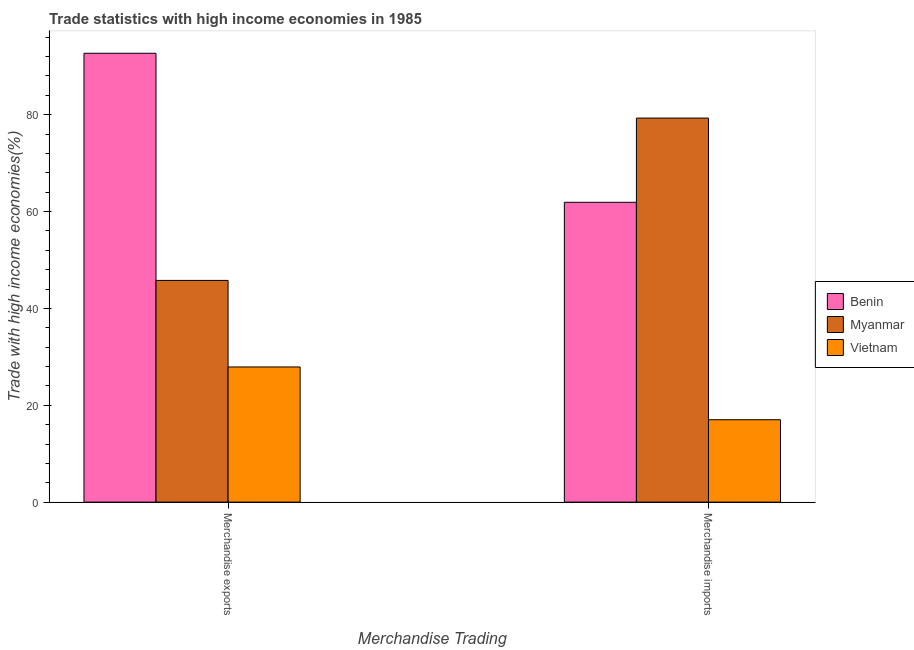How many different coloured bars are there?
Your response must be concise. 3. Are the number of bars per tick equal to the number of legend labels?
Provide a succinct answer. Yes. Are the number of bars on each tick of the X-axis equal?
Your response must be concise. Yes. How many bars are there on the 1st tick from the right?
Offer a terse response. 3. What is the merchandise imports in Myanmar?
Give a very brief answer. 79.29. Across all countries, what is the maximum merchandise exports?
Provide a succinct answer. 92.67. Across all countries, what is the minimum merchandise exports?
Your answer should be very brief. 27.91. In which country was the merchandise imports maximum?
Your response must be concise. Myanmar. In which country was the merchandise imports minimum?
Offer a very short reply. Vietnam. What is the total merchandise imports in the graph?
Your response must be concise. 158.21. What is the difference between the merchandise exports in Vietnam and that in Benin?
Make the answer very short. -64.77. What is the difference between the merchandise imports in Vietnam and the merchandise exports in Benin?
Your answer should be compact. -75.66. What is the average merchandise exports per country?
Your answer should be compact. 55.45. What is the difference between the merchandise exports and merchandise imports in Vietnam?
Your answer should be compact. 10.89. In how many countries, is the merchandise imports greater than 40 %?
Your answer should be compact. 2. What is the ratio of the merchandise exports in Myanmar to that in Benin?
Offer a very short reply. 0.49. Is the merchandise imports in Benin less than that in Myanmar?
Offer a terse response. Yes. What does the 1st bar from the left in Merchandise imports represents?
Your response must be concise. Benin. What does the 3rd bar from the right in Merchandise imports represents?
Keep it short and to the point. Benin. How many bars are there?
Your answer should be very brief. 6. How many countries are there in the graph?
Your answer should be very brief. 3. Does the graph contain grids?
Offer a very short reply. No. Where does the legend appear in the graph?
Provide a short and direct response. Center right. How many legend labels are there?
Your answer should be very brief. 3. How are the legend labels stacked?
Keep it short and to the point. Vertical. What is the title of the graph?
Your answer should be very brief. Trade statistics with high income economies in 1985. Does "Maldives" appear as one of the legend labels in the graph?
Keep it short and to the point. No. What is the label or title of the X-axis?
Your answer should be compact. Merchandise Trading. What is the label or title of the Y-axis?
Give a very brief answer. Trade with high income economies(%). What is the Trade with high income economies(%) in Benin in Merchandise exports?
Your response must be concise. 92.67. What is the Trade with high income economies(%) of Myanmar in Merchandise exports?
Give a very brief answer. 45.78. What is the Trade with high income economies(%) in Vietnam in Merchandise exports?
Offer a very short reply. 27.91. What is the Trade with high income economies(%) of Benin in Merchandise imports?
Your response must be concise. 61.9. What is the Trade with high income economies(%) in Myanmar in Merchandise imports?
Your answer should be very brief. 79.29. What is the Trade with high income economies(%) of Vietnam in Merchandise imports?
Your answer should be very brief. 17.01. Across all Merchandise Trading, what is the maximum Trade with high income economies(%) of Benin?
Provide a short and direct response. 92.67. Across all Merchandise Trading, what is the maximum Trade with high income economies(%) of Myanmar?
Provide a succinct answer. 79.29. Across all Merchandise Trading, what is the maximum Trade with high income economies(%) in Vietnam?
Keep it short and to the point. 27.91. Across all Merchandise Trading, what is the minimum Trade with high income economies(%) in Benin?
Keep it short and to the point. 61.9. Across all Merchandise Trading, what is the minimum Trade with high income economies(%) of Myanmar?
Give a very brief answer. 45.78. Across all Merchandise Trading, what is the minimum Trade with high income economies(%) of Vietnam?
Keep it short and to the point. 17.01. What is the total Trade with high income economies(%) of Benin in the graph?
Provide a succinct answer. 154.58. What is the total Trade with high income economies(%) in Myanmar in the graph?
Your answer should be compact. 125.07. What is the total Trade with high income economies(%) in Vietnam in the graph?
Make the answer very short. 44.92. What is the difference between the Trade with high income economies(%) in Benin in Merchandise exports and that in Merchandise imports?
Provide a succinct answer. 30.77. What is the difference between the Trade with high income economies(%) in Myanmar in Merchandise exports and that in Merchandise imports?
Keep it short and to the point. -33.52. What is the difference between the Trade with high income economies(%) in Vietnam in Merchandise exports and that in Merchandise imports?
Offer a very short reply. 10.89. What is the difference between the Trade with high income economies(%) of Benin in Merchandise exports and the Trade with high income economies(%) of Myanmar in Merchandise imports?
Give a very brief answer. 13.38. What is the difference between the Trade with high income economies(%) in Benin in Merchandise exports and the Trade with high income economies(%) in Vietnam in Merchandise imports?
Offer a very short reply. 75.66. What is the difference between the Trade with high income economies(%) in Myanmar in Merchandise exports and the Trade with high income economies(%) in Vietnam in Merchandise imports?
Offer a terse response. 28.76. What is the average Trade with high income economies(%) of Benin per Merchandise Trading?
Your answer should be very brief. 77.29. What is the average Trade with high income economies(%) of Myanmar per Merchandise Trading?
Give a very brief answer. 62.53. What is the average Trade with high income economies(%) of Vietnam per Merchandise Trading?
Provide a succinct answer. 22.46. What is the difference between the Trade with high income economies(%) of Benin and Trade with high income economies(%) of Myanmar in Merchandise exports?
Offer a very short reply. 46.9. What is the difference between the Trade with high income economies(%) in Benin and Trade with high income economies(%) in Vietnam in Merchandise exports?
Make the answer very short. 64.77. What is the difference between the Trade with high income economies(%) of Myanmar and Trade with high income economies(%) of Vietnam in Merchandise exports?
Make the answer very short. 17.87. What is the difference between the Trade with high income economies(%) of Benin and Trade with high income economies(%) of Myanmar in Merchandise imports?
Give a very brief answer. -17.39. What is the difference between the Trade with high income economies(%) of Benin and Trade with high income economies(%) of Vietnam in Merchandise imports?
Your response must be concise. 44.89. What is the difference between the Trade with high income economies(%) of Myanmar and Trade with high income economies(%) of Vietnam in Merchandise imports?
Offer a terse response. 62.28. What is the ratio of the Trade with high income economies(%) of Benin in Merchandise exports to that in Merchandise imports?
Provide a short and direct response. 1.5. What is the ratio of the Trade with high income economies(%) in Myanmar in Merchandise exports to that in Merchandise imports?
Keep it short and to the point. 0.58. What is the ratio of the Trade with high income economies(%) in Vietnam in Merchandise exports to that in Merchandise imports?
Your answer should be very brief. 1.64. What is the difference between the highest and the second highest Trade with high income economies(%) of Benin?
Make the answer very short. 30.77. What is the difference between the highest and the second highest Trade with high income economies(%) of Myanmar?
Make the answer very short. 33.52. What is the difference between the highest and the second highest Trade with high income economies(%) of Vietnam?
Ensure brevity in your answer.  10.89. What is the difference between the highest and the lowest Trade with high income economies(%) in Benin?
Give a very brief answer. 30.77. What is the difference between the highest and the lowest Trade with high income economies(%) of Myanmar?
Give a very brief answer. 33.52. What is the difference between the highest and the lowest Trade with high income economies(%) in Vietnam?
Your answer should be very brief. 10.89. 